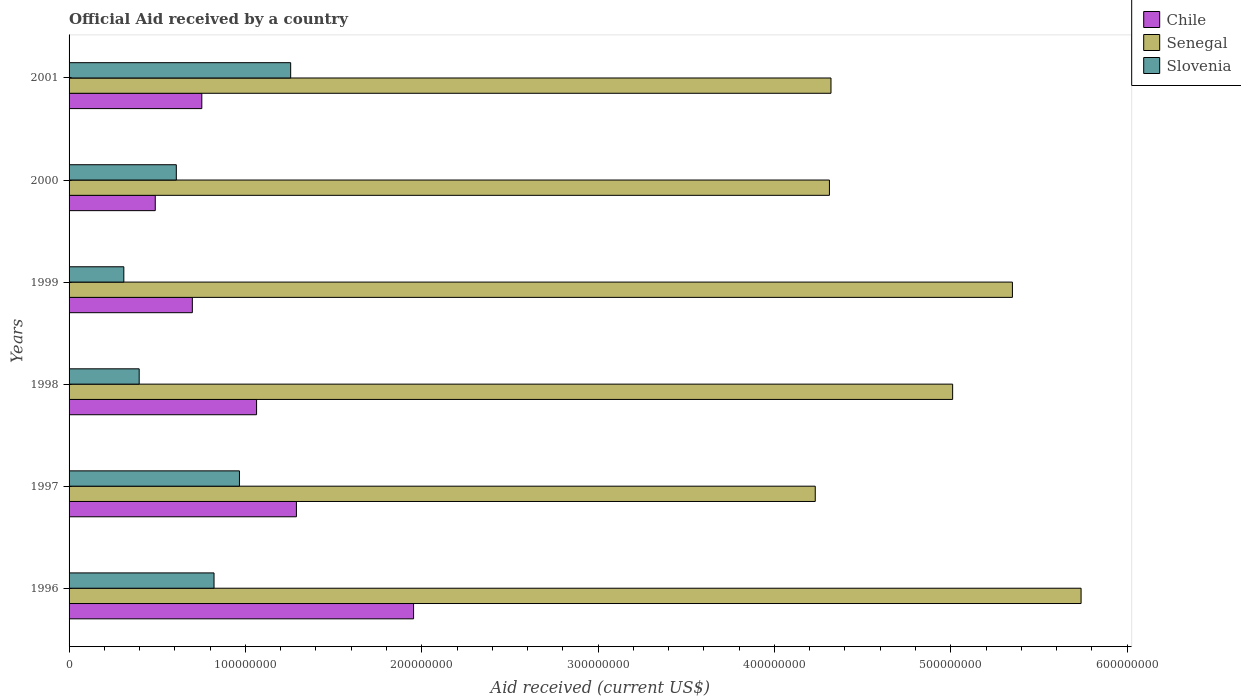How many different coloured bars are there?
Give a very brief answer. 3. How many groups of bars are there?
Your response must be concise. 6. How many bars are there on the 2nd tick from the top?
Offer a very short reply. 3. How many bars are there on the 4th tick from the bottom?
Offer a terse response. 3. What is the net official aid received in Slovenia in 2000?
Provide a succinct answer. 6.08e+07. Across all years, what is the maximum net official aid received in Senegal?
Give a very brief answer. 5.74e+08. Across all years, what is the minimum net official aid received in Chile?
Your answer should be very brief. 4.89e+07. In which year was the net official aid received in Senegal maximum?
Provide a succinct answer. 1996. In which year was the net official aid received in Senegal minimum?
Offer a very short reply. 1997. What is the total net official aid received in Senegal in the graph?
Provide a short and direct response. 2.90e+09. What is the difference between the net official aid received in Slovenia in 1997 and that in 2001?
Make the answer very short. -2.90e+07. What is the difference between the net official aid received in Senegal in 1998 and the net official aid received in Slovenia in 1999?
Your answer should be very brief. 4.70e+08. What is the average net official aid received in Chile per year?
Your response must be concise. 1.04e+08. In the year 1996, what is the difference between the net official aid received in Chile and net official aid received in Slovenia?
Your response must be concise. 1.13e+08. What is the ratio of the net official aid received in Senegal in 1996 to that in 2001?
Provide a short and direct response. 1.33. Is the net official aid received in Senegal in 1996 less than that in 1998?
Your answer should be very brief. No. What is the difference between the highest and the second highest net official aid received in Senegal?
Make the answer very short. 3.89e+07. What is the difference between the highest and the lowest net official aid received in Slovenia?
Give a very brief answer. 9.46e+07. What does the 3rd bar from the top in 1996 represents?
Give a very brief answer. Chile. Is it the case that in every year, the sum of the net official aid received in Senegal and net official aid received in Slovenia is greater than the net official aid received in Chile?
Provide a succinct answer. Yes. Does the graph contain any zero values?
Offer a very short reply. No. Where does the legend appear in the graph?
Provide a succinct answer. Top right. How many legend labels are there?
Your response must be concise. 3. What is the title of the graph?
Your answer should be very brief. Official Aid received by a country. Does "Ghana" appear as one of the legend labels in the graph?
Your answer should be compact. No. What is the label or title of the X-axis?
Give a very brief answer. Aid received (current US$). What is the label or title of the Y-axis?
Your answer should be compact. Years. What is the Aid received (current US$) of Chile in 1996?
Keep it short and to the point. 1.95e+08. What is the Aid received (current US$) of Senegal in 1996?
Keep it short and to the point. 5.74e+08. What is the Aid received (current US$) in Slovenia in 1996?
Offer a terse response. 8.22e+07. What is the Aid received (current US$) of Chile in 1997?
Your response must be concise. 1.29e+08. What is the Aid received (current US$) of Senegal in 1997?
Give a very brief answer. 4.23e+08. What is the Aid received (current US$) in Slovenia in 1997?
Your answer should be very brief. 9.66e+07. What is the Aid received (current US$) in Chile in 1998?
Offer a terse response. 1.06e+08. What is the Aid received (current US$) in Senegal in 1998?
Provide a succinct answer. 5.01e+08. What is the Aid received (current US$) of Slovenia in 1998?
Make the answer very short. 3.98e+07. What is the Aid received (current US$) of Chile in 1999?
Ensure brevity in your answer.  6.99e+07. What is the Aid received (current US$) in Senegal in 1999?
Offer a very short reply. 5.35e+08. What is the Aid received (current US$) in Slovenia in 1999?
Your answer should be very brief. 3.10e+07. What is the Aid received (current US$) of Chile in 2000?
Your answer should be very brief. 4.89e+07. What is the Aid received (current US$) of Senegal in 2000?
Your answer should be compact. 4.31e+08. What is the Aid received (current US$) of Slovenia in 2000?
Your response must be concise. 6.08e+07. What is the Aid received (current US$) of Chile in 2001?
Give a very brief answer. 7.53e+07. What is the Aid received (current US$) of Senegal in 2001?
Ensure brevity in your answer.  4.32e+08. What is the Aid received (current US$) of Slovenia in 2001?
Ensure brevity in your answer.  1.26e+08. Across all years, what is the maximum Aid received (current US$) in Chile?
Your response must be concise. 1.95e+08. Across all years, what is the maximum Aid received (current US$) in Senegal?
Your answer should be very brief. 5.74e+08. Across all years, what is the maximum Aid received (current US$) in Slovenia?
Offer a very short reply. 1.26e+08. Across all years, what is the minimum Aid received (current US$) of Chile?
Offer a terse response. 4.89e+07. Across all years, what is the minimum Aid received (current US$) of Senegal?
Offer a very short reply. 4.23e+08. Across all years, what is the minimum Aid received (current US$) of Slovenia?
Give a very brief answer. 3.10e+07. What is the total Aid received (current US$) of Chile in the graph?
Offer a terse response. 6.25e+08. What is the total Aid received (current US$) of Senegal in the graph?
Provide a succinct answer. 2.90e+09. What is the total Aid received (current US$) of Slovenia in the graph?
Your response must be concise. 4.36e+08. What is the difference between the Aid received (current US$) in Chile in 1996 and that in 1997?
Your answer should be very brief. 6.64e+07. What is the difference between the Aid received (current US$) in Senegal in 1996 and that in 1997?
Offer a very short reply. 1.51e+08. What is the difference between the Aid received (current US$) of Slovenia in 1996 and that in 1997?
Your answer should be very brief. -1.44e+07. What is the difference between the Aid received (current US$) of Chile in 1996 and that in 1998?
Keep it short and to the point. 8.90e+07. What is the difference between the Aid received (current US$) of Senegal in 1996 and that in 1998?
Offer a very short reply. 7.28e+07. What is the difference between the Aid received (current US$) in Slovenia in 1996 and that in 1998?
Ensure brevity in your answer.  4.24e+07. What is the difference between the Aid received (current US$) in Chile in 1996 and that in 1999?
Provide a short and direct response. 1.25e+08. What is the difference between the Aid received (current US$) of Senegal in 1996 and that in 1999?
Give a very brief answer. 3.89e+07. What is the difference between the Aid received (current US$) in Slovenia in 1996 and that in 1999?
Offer a very short reply. 5.12e+07. What is the difference between the Aid received (current US$) of Chile in 1996 and that in 2000?
Offer a terse response. 1.46e+08. What is the difference between the Aid received (current US$) in Senegal in 1996 and that in 2000?
Ensure brevity in your answer.  1.43e+08. What is the difference between the Aid received (current US$) of Slovenia in 1996 and that in 2000?
Keep it short and to the point. 2.14e+07. What is the difference between the Aid received (current US$) of Chile in 1996 and that in 2001?
Offer a terse response. 1.20e+08. What is the difference between the Aid received (current US$) of Senegal in 1996 and that in 2001?
Keep it short and to the point. 1.42e+08. What is the difference between the Aid received (current US$) in Slovenia in 1996 and that in 2001?
Make the answer very short. -4.35e+07. What is the difference between the Aid received (current US$) in Chile in 1997 and that in 1998?
Keep it short and to the point. 2.26e+07. What is the difference between the Aid received (current US$) in Senegal in 1997 and that in 1998?
Make the answer very short. -7.79e+07. What is the difference between the Aid received (current US$) in Slovenia in 1997 and that in 1998?
Keep it short and to the point. 5.69e+07. What is the difference between the Aid received (current US$) of Chile in 1997 and that in 1999?
Your answer should be very brief. 5.90e+07. What is the difference between the Aid received (current US$) of Senegal in 1997 and that in 1999?
Make the answer very short. -1.12e+08. What is the difference between the Aid received (current US$) of Slovenia in 1997 and that in 1999?
Offer a very short reply. 6.56e+07. What is the difference between the Aid received (current US$) of Chile in 1997 and that in 2000?
Give a very brief answer. 8.00e+07. What is the difference between the Aid received (current US$) of Senegal in 1997 and that in 2000?
Make the answer very short. -8.04e+06. What is the difference between the Aid received (current US$) in Slovenia in 1997 and that in 2000?
Your answer should be very brief. 3.58e+07. What is the difference between the Aid received (current US$) of Chile in 1997 and that in 2001?
Ensure brevity in your answer.  5.36e+07. What is the difference between the Aid received (current US$) in Senegal in 1997 and that in 2001?
Provide a short and direct response. -8.92e+06. What is the difference between the Aid received (current US$) of Slovenia in 1997 and that in 2001?
Provide a short and direct response. -2.90e+07. What is the difference between the Aid received (current US$) of Chile in 1998 and that in 1999?
Give a very brief answer. 3.64e+07. What is the difference between the Aid received (current US$) in Senegal in 1998 and that in 1999?
Offer a very short reply. -3.39e+07. What is the difference between the Aid received (current US$) in Slovenia in 1998 and that in 1999?
Offer a very short reply. 8.71e+06. What is the difference between the Aid received (current US$) in Chile in 1998 and that in 2000?
Ensure brevity in your answer.  5.74e+07. What is the difference between the Aid received (current US$) of Senegal in 1998 and that in 2000?
Make the answer very short. 6.99e+07. What is the difference between the Aid received (current US$) of Slovenia in 1998 and that in 2000?
Your answer should be compact. -2.10e+07. What is the difference between the Aid received (current US$) of Chile in 1998 and that in 2001?
Provide a short and direct response. 3.11e+07. What is the difference between the Aid received (current US$) of Senegal in 1998 and that in 2001?
Provide a succinct answer. 6.90e+07. What is the difference between the Aid received (current US$) of Slovenia in 1998 and that in 2001?
Provide a succinct answer. -8.59e+07. What is the difference between the Aid received (current US$) of Chile in 1999 and that in 2000?
Your response must be concise. 2.10e+07. What is the difference between the Aid received (current US$) in Senegal in 1999 and that in 2000?
Your answer should be very brief. 1.04e+08. What is the difference between the Aid received (current US$) in Slovenia in 1999 and that in 2000?
Your answer should be compact. -2.98e+07. What is the difference between the Aid received (current US$) of Chile in 1999 and that in 2001?
Your answer should be compact. -5.37e+06. What is the difference between the Aid received (current US$) of Senegal in 1999 and that in 2001?
Ensure brevity in your answer.  1.03e+08. What is the difference between the Aid received (current US$) in Slovenia in 1999 and that in 2001?
Offer a terse response. -9.46e+07. What is the difference between the Aid received (current US$) in Chile in 2000 and that in 2001?
Provide a short and direct response. -2.64e+07. What is the difference between the Aid received (current US$) in Senegal in 2000 and that in 2001?
Your answer should be compact. -8.80e+05. What is the difference between the Aid received (current US$) in Slovenia in 2000 and that in 2001?
Ensure brevity in your answer.  -6.48e+07. What is the difference between the Aid received (current US$) of Chile in 1996 and the Aid received (current US$) of Senegal in 1997?
Offer a very short reply. -2.28e+08. What is the difference between the Aid received (current US$) in Chile in 1996 and the Aid received (current US$) in Slovenia in 1997?
Offer a terse response. 9.87e+07. What is the difference between the Aid received (current US$) of Senegal in 1996 and the Aid received (current US$) of Slovenia in 1997?
Offer a terse response. 4.77e+08. What is the difference between the Aid received (current US$) of Chile in 1996 and the Aid received (current US$) of Senegal in 1998?
Make the answer very short. -3.06e+08. What is the difference between the Aid received (current US$) of Chile in 1996 and the Aid received (current US$) of Slovenia in 1998?
Your answer should be very brief. 1.56e+08. What is the difference between the Aid received (current US$) of Senegal in 1996 and the Aid received (current US$) of Slovenia in 1998?
Make the answer very short. 5.34e+08. What is the difference between the Aid received (current US$) of Chile in 1996 and the Aid received (current US$) of Senegal in 1999?
Offer a terse response. -3.40e+08. What is the difference between the Aid received (current US$) in Chile in 1996 and the Aid received (current US$) in Slovenia in 1999?
Provide a short and direct response. 1.64e+08. What is the difference between the Aid received (current US$) of Senegal in 1996 and the Aid received (current US$) of Slovenia in 1999?
Give a very brief answer. 5.43e+08. What is the difference between the Aid received (current US$) of Chile in 1996 and the Aid received (current US$) of Senegal in 2000?
Give a very brief answer. -2.36e+08. What is the difference between the Aid received (current US$) of Chile in 1996 and the Aid received (current US$) of Slovenia in 2000?
Give a very brief answer. 1.35e+08. What is the difference between the Aid received (current US$) in Senegal in 1996 and the Aid received (current US$) in Slovenia in 2000?
Give a very brief answer. 5.13e+08. What is the difference between the Aid received (current US$) of Chile in 1996 and the Aid received (current US$) of Senegal in 2001?
Your answer should be compact. -2.37e+08. What is the difference between the Aid received (current US$) in Chile in 1996 and the Aid received (current US$) in Slovenia in 2001?
Your response must be concise. 6.97e+07. What is the difference between the Aid received (current US$) of Senegal in 1996 and the Aid received (current US$) of Slovenia in 2001?
Your response must be concise. 4.48e+08. What is the difference between the Aid received (current US$) in Chile in 1997 and the Aid received (current US$) in Senegal in 1998?
Provide a succinct answer. -3.72e+08. What is the difference between the Aid received (current US$) of Chile in 1997 and the Aid received (current US$) of Slovenia in 1998?
Provide a succinct answer. 8.92e+07. What is the difference between the Aid received (current US$) of Senegal in 1997 and the Aid received (current US$) of Slovenia in 1998?
Provide a short and direct response. 3.83e+08. What is the difference between the Aid received (current US$) of Chile in 1997 and the Aid received (current US$) of Senegal in 1999?
Offer a terse response. -4.06e+08. What is the difference between the Aid received (current US$) of Chile in 1997 and the Aid received (current US$) of Slovenia in 1999?
Give a very brief answer. 9.79e+07. What is the difference between the Aid received (current US$) in Senegal in 1997 and the Aid received (current US$) in Slovenia in 1999?
Provide a succinct answer. 3.92e+08. What is the difference between the Aid received (current US$) of Chile in 1997 and the Aid received (current US$) of Senegal in 2000?
Offer a terse response. -3.02e+08. What is the difference between the Aid received (current US$) in Chile in 1997 and the Aid received (current US$) in Slovenia in 2000?
Your answer should be very brief. 6.81e+07. What is the difference between the Aid received (current US$) of Senegal in 1997 and the Aid received (current US$) of Slovenia in 2000?
Ensure brevity in your answer.  3.62e+08. What is the difference between the Aid received (current US$) in Chile in 1997 and the Aid received (current US$) in Senegal in 2001?
Your answer should be very brief. -3.03e+08. What is the difference between the Aid received (current US$) in Chile in 1997 and the Aid received (current US$) in Slovenia in 2001?
Your answer should be compact. 3.26e+06. What is the difference between the Aid received (current US$) of Senegal in 1997 and the Aid received (current US$) of Slovenia in 2001?
Offer a terse response. 2.97e+08. What is the difference between the Aid received (current US$) of Chile in 1998 and the Aid received (current US$) of Senegal in 1999?
Provide a succinct answer. -4.29e+08. What is the difference between the Aid received (current US$) in Chile in 1998 and the Aid received (current US$) in Slovenia in 1999?
Ensure brevity in your answer.  7.53e+07. What is the difference between the Aid received (current US$) in Senegal in 1998 and the Aid received (current US$) in Slovenia in 1999?
Offer a very short reply. 4.70e+08. What is the difference between the Aid received (current US$) of Chile in 1998 and the Aid received (current US$) of Senegal in 2000?
Make the answer very short. -3.25e+08. What is the difference between the Aid received (current US$) in Chile in 1998 and the Aid received (current US$) in Slovenia in 2000?
Your response must be concise. 4.55e+07. What is the difference between the Aid received (current US$) of Senegal in 1998 and the Aid received (current US$) of Slovenia in 2000?
Ensure brevity in your answer.  4.40e+08. What is the difference between the Aid received (current US$) in Chile in 1998 and the Aid received (current US$) in Senegal in 2001?
Offer a terse response. -3.26e+08. What is the difference between the Aid received (current US$) of Chile in 1998 and the Aid received (current US$) of Slovenia in 2001?
Keep it short and to the point. -1.93e+07. What is the difference between the Aid received (current US$) of Senegal in 1998 and the Aid received (current US$) of Slovenia in 2001?
Your answer should be compact. 3.75e+08. What is the difference between the Aid received (current US$) in Chile in 1999 and the Aid received (current US$) in Senegal in 2000?
Give a very brief answer. -3.61e+08. What is the difference between the Aid received (current US$) of Chile in 1999 and the Aid received (current US$) of Slovenia in 2000?
Provide a succinct answer. 9.09e+06. What is the difference between the Aid received (current US$) of Senegal in 1999 and the Aid received (current US$) of Slovenia in 2000?
Ensure brevity in your answer.  4.74e+08. What is the difference between the Aid received (current US$) in Chile in 1999 and the Aid received (current US$) in Senegal in 2001?
Ensure brevity in your answer.  -3.62e+08. What is the difference between the Aid received (current US$) in Chile in 1999 and the Aid received (current US$) in Slovenia in 2001?
Provide a short and direct response. -5.58e+07. What is the difference between the Aid received (current US$) of Senegal in 1999 and the Aid received (current US$) of Slovenia in 2001?
Make the answer very short. 4.09e+08. What is the difference between the Aid received (current US$) in Chile in 2000 and the Aid received (current US$) in Senegal in 2001?
Provide a short and direct response. -3.83e+08. What is the difference between the Aid received (current US$) of Chile in 2000 and the Aid received (current US$) of Slovenia in 2001?
Your response must be concise. -7.68e+07. What is the difference between the Aid received (current US$) in Senegal in 2000 and the Aid received (current US$) in Slovenia in 2001?
Give a very brief answer. 3.06e+08. What is the average Aid received (current US$) of Chile per year?
Provide a short and direct response. 1.04e+08. What is the average Aid received (current US$) in Senegal per year?
Offer a terse response. 4.83e+08. What is the average Aid received (current US$) of Slovenia per year?
Make the answer very short. 7.27e+07. In the year 1996, what is the difference between the Aid received (current US$) in Chile and Aid received (current US$) in Senegal?
Your response must be concise. -3.79e+08. In the year 1996, what is the difference between the Aid received (current US$) in Chile and Aid received (current US$) in Slovenia?
Provide a succinct answer. 1.13e+08. In the year 1996, what is the difference between the Aid received (current US$) of Senegal and Aid received (current US$) of Slovenia?
Offer a very short reply. 4.92e+08. In the year 1997, what is the difference between the Aid received (current US$) in Chile and Aid received (current US$) in Senegal?
Give a very brief answer. -2.94e+08. In the year 1997, what is the difference between the Aid received (current US$) of Chile and Aid received (current US$) of Slovenia?
Give a very brief answer. 3.23e+07. In the year 1997, what is the difference between the Aid received (current US$) in Senegal and Aid received (current US$) in Slovenia?
Make the answer very short. 3.27e+08. In the year 1998, what is the difference between the Aid received (current US$) in Chile and Aid received (current US$) in Senegal?
Offer a very short reply. -3.95e+08. In the year 1998, what is the difference between the Aid received (current US$) of Chile and Aid received (current US$) of Slovenia?
Provide a succinct answer. 6.66e+07. In the year 1998, what is the difference between the Aid received (current US$) of Senegal and Aid received (current US$) of Slovenia?
Give a very brief answer. 4.61e+08. In the year 1999, what is the difference between the Aid received (current US$) in Chile and Aid received (current US$) in Senegal?
Offer a terse response. -4.65e+08. In the year 1999, what is the difference between the Aid received (current US$) in Chile and Aid received (current US$) in Slovenia?
Provide a short and direct response. 3.88e+07. In the year 1999, what is the difference between the Aid received (current US$) of Senegal and Aid received (current US$) of Slovenia?
Your response must be concise. 5.04e+08. In the year 2000, what is the difference between the Aid received (current US$) in Chile and Aid received (current US$) in Senegal?
Make the answer very short. -3.82e+08. In the year 2000, what is the difference between the Aid received (current US$) of Chile and Aid received (current US$) of Slovenia?
Your response must be concise. -1.19e+07. In the year 2000, what is the difference between the Aid received (current US$) of Senegal and Aid received (current US$) of Slovenia?
Keep it short and to the point. 3.70e+08. In the year 2001, what is the difference between the Aid received (current US$) of Chile and Aid received (current US$) of Senegal?
Make the answer very short. -3.57e+08. In the year 2001, what is the difference between the Aid received (current US$) of Chile and Aid received (current US$) of Slovenia?
Offer a terse response. -5.04e+07. In the year 2001, what is the difference between the Aid received (current US$) of Senegal and Aid received (current US$) of Slovenia?
Provide a succinct answer. 3.06e+08. What is the ratio of the Aid received (current US$) in Chile in 1996 to that in 1997?
Give a very brief answer. 1.52. What is the ratio of the Aid received (current US$) in Senegal in 1996 to that in 1997?
Keep it short and to the point. 1.36. What is the ratio of the Aid received (current US$) of Slovenia in 1996 to that in 1997?
Give a very brief answer. 0.85. What is the ratio of the Aid received (current US$) of Chile in 1996 to that in 1998?
Ensure brevity in your answer.  1.84. What is the ratio of the Aid received (current US$) in Senegal in 1996 to that in 1998?
Provide a succinct answer. 1.15. What is the ratio of the Aid received (current US$) of Slovenia in 1996 to that in 1998?
Provide a succinct answer. 2.07. What is the ratio of the Aid received (current US$) in Chile in 1996 to that in 1999?
Your answer should be compact. 2.79. What is the ratio of the Aid received (current US$) of Senegal in 1996 to that in 1999?
Your answer should be very brief. 1.07. What is the ratio of the Aid received (current US$) in Slovenia in 1996 to that in 1999?
Provide a succinct answer. 2.65. What is the ratio of the Aid received (current US$) in Chile in 1996 to that in 2000?
Offer a very short reply. 4. What is the ratio of the Aid received (current US$) in Senegal in 1996 to that in 2000?
Your answer should be compact. 1.33. What is the ratio of the Aid received (current US$) in Slovenia in 1996 to that in 2000?
Offer a terse response. 1.35. What is the ratio of the Aid received (current US$) of Chile in 1996 to that in 2001?
Your answer should be compact. 2.6. What is the ratio of the Aid received (current US$) of Senegal in 1996 to that in 2001?
Offer a very short reply. 1.33. What is the ratio of the Aid received (current US$) of Slovenia in 1996 to that in 2001?
Provide a succinct answer. 0.65. What is the ratio of the Aid received (current US$) in Chile in 1997 to that in 1998?
Make the answer very short. 1.21. What is the ratio of the Aid received (current US$) of Senegal in 1997 to that in 1998?
Ensure brevity in your answer.  0.84. What is the ratio of the Aid received (current US$) in Slovenia in 1997 to that in 1998?
Offer a very short reply. 2.43. What is the ratio of the Aid received (current US$) in Chile in 1997 to that in 1999?
Your answer should be very brief. 1.84. What is the ratio of the Aid received (current US$) of Senegal in 1997 to that in 1999?
Provide a succinct answer. 0.79. What is the ratio of the Aid received (current US$) in Slovenia in 1997 to that in 1999?
Your answer should be compact. 3.11. What is the ratio of the Aid received (current US$) in Chile in 1997 to that in 2000?
Offer a terse response. 2.64. What is the ratio of the Aid received (current US$) in Senegal in 1997 to that in 2000?
Your answer should be very brief. 0.98. What is the ratio of the Aid received (current US$) in Slovenia in 1997 to that in 2000?
Offer a terse response. 1.59. What is the ratio of the Aid received (current US$) of Chile in 1997 to that in 2001?
Give a very brief answer. 1.71. What is the ratio of the Aid received (current US$) in Senegal in 1997 to that in 2001?
Provide a succinct answer. 0.98. What is the ratio of the Aid received (current US$) of Slovenia in 1997 to that in 2001?
Provide a succinct answer. 0.77. What is the ratio of the Aid received (current US$) in Chile in 1998 to that in 1999?
Ensure brevity in your answer.  1.52. What is the ratio of the Aid received (current US$) of Senegal in 1998 to that in 1999?
Your response must be concise. 0.94. What is the ratio of the Aid received (current US$) in Slovenia in 1998 to that in 1999?
Offer a very short reply. 1.28. What is the ratio of the Aid received (current US$) in Chile in 1998 to that in 2000?
Keep it short and to the point. 2.18. What is the ratio of the Aid received (current US$) in Senegal in 1998 to that in 2000?
Keep it short and to the point. 1.16. What is the ratio of the Aid received (current US$) of Slovenia in 1998 to that in 2000?
Provide a short and direct response. 0.65. What is the ratio of the Aid received (current US$) of Chile in 1998 to that in 2001?
Offer a very short reply. 1.41. What is the ratio of the Aid received (current US$) of Senegal in 1998 to that in 2001?
Ensure brevity in your answer.  1.16. What is the ratio of the Aid received (current US$) in Slovenia in 1998 to that in 2001?
Keep it short and to the point. 0.32. What is the ratio of the Aid received (current US$) of Chile in 1999 to that in 2000?
Keep it short and to the point. 1.43. What is the ratio of the Aid received (current US$) in Senegal in 1999 to that in 2000?
Provide a short and direct response. 1.24. What is the ratio of the Aid received (current US$) of Slovenia in 1999 to that in 2000?
Give a very brief answer. 0.51. What is the ratio of the Aid received (current US$) of Chile in 1999 to that in 2001?
Give a very brief answer. 0.93. What is the ratio of the Aid received (current US$) of Senegal in 1999 to that in 2001?
Your answer should be very brief. 1.24. What is the ratio of the Aid received (current US$) in Slovenia in 1999 to that in 2001?
Your answer should be compact. 0.25. What is the ratio of the Aid received (current US$) of Chile in 2000 to that in 2001?
Offer a very short reply. 0.65. What is the ratio of the Aid received (current US$) of Senegal in 2000 to that in 2001?
Give a very brief answer. 1. What is the ratio of the Aid received (current US$) in Slovenia in 2000 to that in 2001?
Provide a short and direct response. 0.48. What is the difference between the highest and the second highest Aid received (current US$) in Chile?
Your answer should be compact. 6.64e+07. What is the difference between the highest and the second highest Aid received (current US$) in Senegal?
Ensure brevity in your answer.  3.89e+07. What is the difference between the highest and the second highest Aid received (current US$) in Slovenia?
Give a very brief answer. 2.90e+07. What is the difference between the highest and the lowest Aid received (current US$) in Chile?
Your response must be concise. 1.46e+08. What is the difference between the highest and the lowest Aid received (current US$) of Senegal?
Make the answer very short. 1.51e+08. What is the difference between the highest and the lowest Aid received (current US$) of Slovenia?
Ensure brevity in your answer.  9.46e+07. 